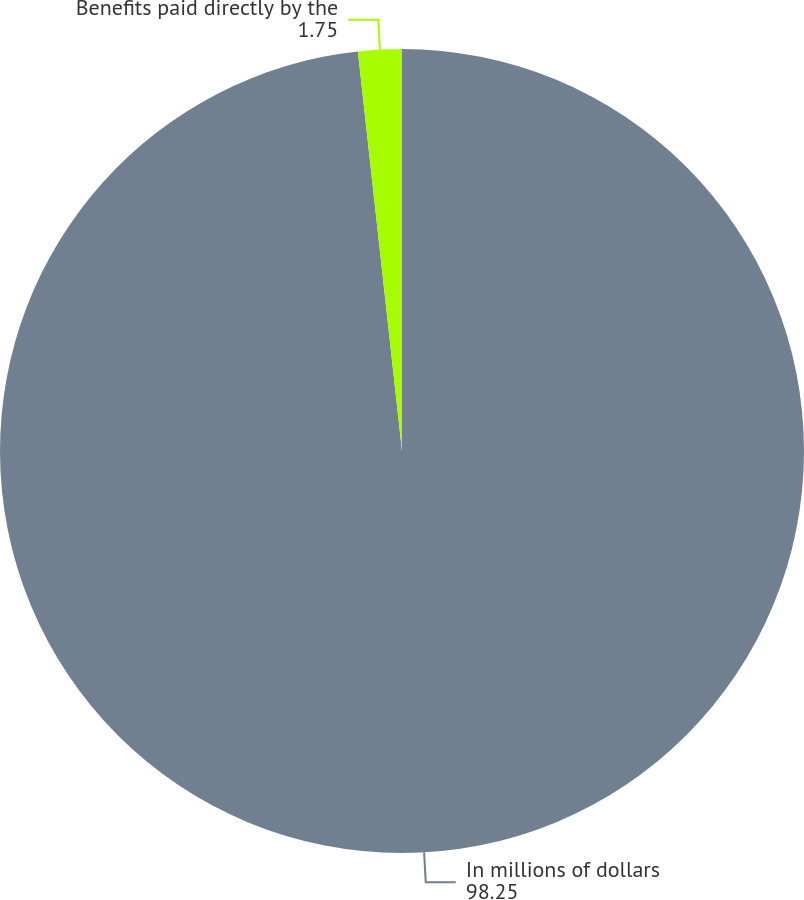Convert chart. <chart><loc_0><loc_0><loc_500><loc_500><pie_chart><fcel>In millions of dollars<fcel>Benefits paid directly by the<nl><fcel>98.25%<fcel>1.75%<nl></chart> 